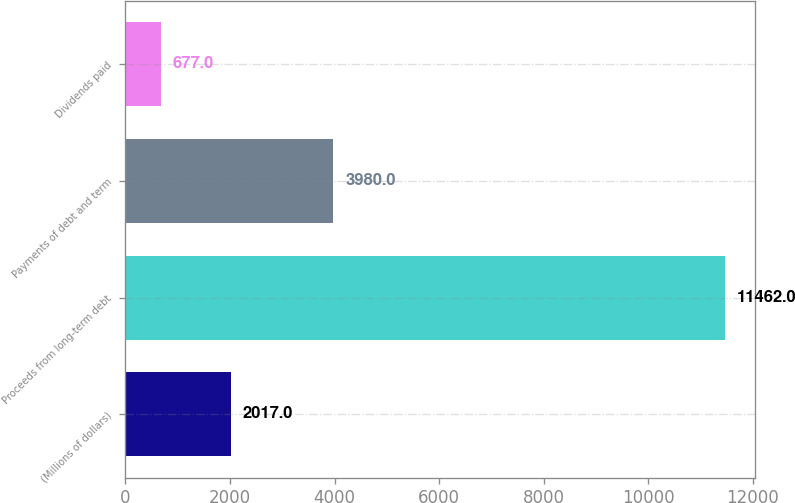<chart> <loc_0><loc_0><loc_500><loc_500><bar_chart><fcel>(Millions of dollars)<fcel>Proceeds from long-term debt<fcel>Payments of debt and term<fcel>Dividends paid<nl><fcel>2017<fcel>11462<fcel>3980<fcel>677<nl></chart> 